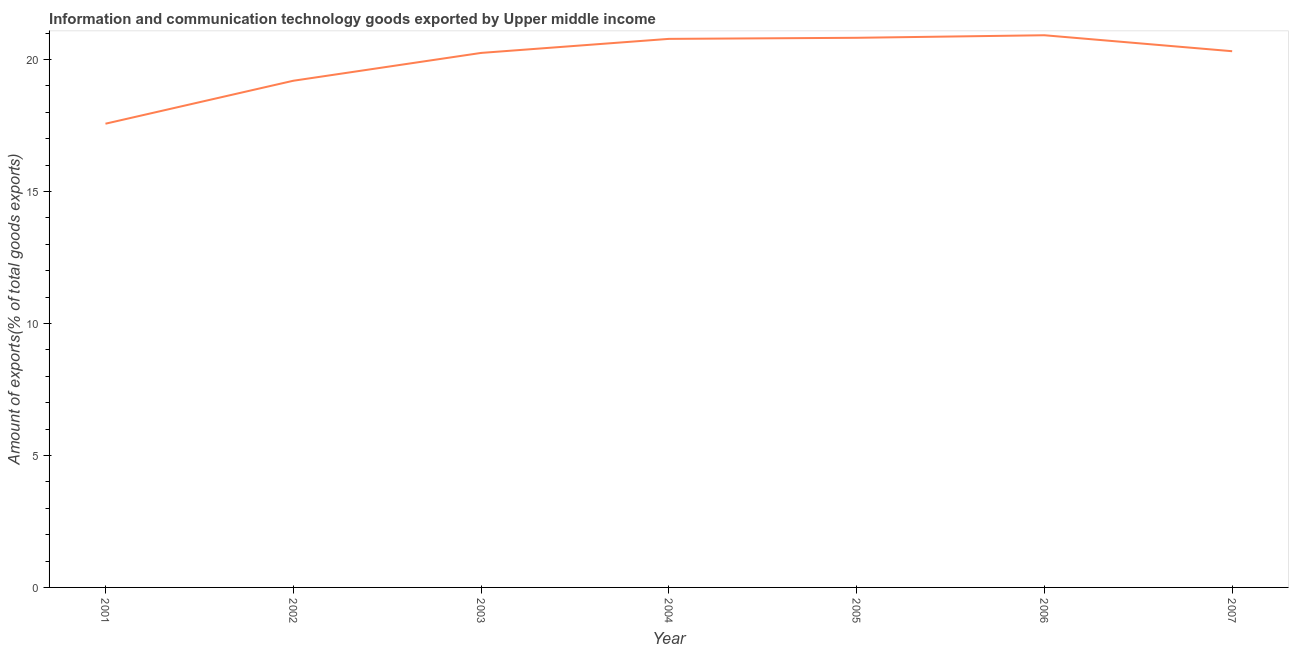What is the amount of ict goods exports in 2004?
Ensure brevity in your answer.  20.78. Across all years, what is the maximum amount of ict goods exports?
Offer a terse response. 20.92. Across all years, what is the minimum amount of ict goods exports?
Your answer should be very brief. 17.57. What is the sum of the amount of ict goods exports?
Provide a succinct answer. 139.87. What is the difference between the amount of ict goods exports in 2005 and 2007?
Make the answer very short. 0.51. What is the average amount of ict goods exports per year?
Provide a succinct answer. 19.98. What is the median amount of ict goods exports?
Ensure brevity in your answer.  20.32. In how many years, is the amount of ict goods exports greater than 12 %?
Provide a succinct answer. 7. Do a majority of the years between 2003 and 2002 (inclusive) have amount of ict goods exports greater than 15 %?
Your answer should be very brief. No. What is the ratio of the amount of ict goods exports in 2001 to that in 2002?
Ensure brevity in your answer.  0.92. Is the amount of ict goods exports in 2001 less than that in 2004?
Provide a short and direct response. Yes. Is the difference between the amount of ict goods exports in 2002 and 2006 greater than the difference between any two years?
Ensure brevity in your answer.  No. What is the difference between the highest and the second highest amount of ict goods exports?
Your answer should be compact. 0.1. What is the difference between the highest and the lowest amount of ict goods exports?
Offer a terse response. 3.35. In how many years, is the amount of ict goods exports greater than the average amount of ict goods exports taken over all years?
Make the answer very short. 5. How many lines are there?
Your answer should be compact. 1. What is the difference between two consecutive major ticks on the Y-axis?
Your response must be concise. 5. Are the values on the major ticks of Y-axis written in scientific E-notation?
Make the answer very short. No. Does the graph contain any zero values?
Keep it short and to the point. No. Does the graph contain grids?
Make the answer very short. No. What is the title of the graph?
Your answer should be very brief. Information and communication technology goods exported by Upper middle income. What is the label or title of the Y-axis?
Provide a succinct answer. Amount of exports(% of total goods exports). What is the Amount of exports(% of total goods exports) of 2001?
Keep it short and to the point. 17.57. What is the Amount of exports(% of total goods exports) in 2002?
Give a very brief answer. 19.2. What is the Amount of exports(% of total goods exports) in 2003?
Provide a short and direct response. 20.25. What is the Amount of exports(% of total goods exports) in 2004?
Provide a succinct answer. 20.78. What is the Amount of exports(% of total goods exports) in 2005?
Offer a terse response. 20.83. What is the Amount of exports(% of total goods exports) of 2006?
Your answer should be compact. 20.92. What is the Amount of exports(% of total goods exports) in 2007?
Your response must be concise. 20.32. What is the difference between the Amount of exports(% of total goods exports) in 2001 and 2002?
Ensure brevity in your answer.  -1.63. What is the difference between the Amount of exports(% of total goods exports) in 2001 and 2003?
Give a very brief answer. -2.68. What is the difference between the Amount of exports(% of total goods exports) in 2001 and 2004?
Ensure brevity in your answer.  -3.21. What is the difference between the Amount of exports(% of total goods exports) in 2001 and 2005?
Offer a very short reply. -3.26. What is the difference between the Amount of exports(% of total goods exports) in 2001 and 2006?
Give a very brief answer. -3.35. What is the difference between the Amount of exports(% of total goods exports) in 2001 and 2007?
Provide a succinct answer. -2.75. What is the difference between the Amount of exports(% of total goods exports) in 2002 and 2003?
Provide a succinct answer. -1.05. What is the difference between the Amount of exports(% of total goods exports) in 2002 and 2004?
Offer a terse response. -1.59. What is the difference between the Amount of exports(% of total goods exports) in 2002 and 2005?
Provide a succinct answer. -1.63. What is the difference between the Amount of exports(% of total goods exports) in 2002 and 2006?
Provide a short and direct response. -1.72. What is the difference between the Amount of exports(% of total goods exports) in 2002 and 2007?
Provide a short and direct response. -1.12. What is the difference between the Amount of exports(% of total goods exports) in 2003 and 2004?
Your answer should be very brief. -0.53. What is the difference between the Amount of exports(% of total goods exports) in 2003 and 2005?
Your answer should be very brief. -0.57. What is the difference between the Amount of exports(% of total goods exports) in 2003 and 2006?
Make the answer very short. -0.67. What is the difference between the Amount of exports(% of total goods exports) in 2003 and 2007?
Provide a short and direct response. -0.06. What is the difference between the Amount of exports(% of total goods exports) in 2004 and 2005?
Offer a terse response. -0.04. What is the difference between the Amount of exports(% of total goods exports) in 2004 and 2006?
Make the answer very short. -0.14. What is the difference between the Amount of exports(% of total goods exports) in 2004 and 2007?
Offer a very short reply. 0.47. What is the difference between the Amount of exports(% of total goods exports) in 2005 and 2006?
Your response must be concise. -0.1. What is the difference between the Amount of exports(% of total goods exports) in 2005 and 2007?
Make the answer very short. 0.51. What is the difference between the Amount of exports(% of total goods exports) in 2006 and 2007?
Ensure brevity in your answer.  0.6. What is the ratio of the Amount of exports(% of total goods exports) in 2001 to that in 2002?
Ensure brevity in your answer.  0.92. What is the ratio of the Amount of exports(% of total goods exports) in 2001 to that in 2003?
Your response must be concise. 0.87. What is the ratio of the Amount of exports(% of total goods exports) in 2001 to that in 2004?
Provide a short and direct response. 0.84. What is the ratio of the Amount of exports(% of total goods exports) in 2001 to that in 2005?
Your response must be concise. 0.84. What is the ratio of the Amount of exports(% of total goods exports) in 2001 to that in 2006?
Offer a terse response. 0.84. What is the ratio of the Amount of exports(% of total goods exports) in 2001 to that in 2007?
Make the answer very short. 0.86. What is the ratio of the Amount of exports(% of total goods exports) in 2002 to that in 2003?
Provide a short and direct response. 0.95. What is the ratio of the Amount of exports(% of total goods exports) in 2002 to that in 2004?
Provide a short and direct response. 0.92. What is the ratio of the Amount of exports(% of total goods exports) in 2002 to that in 2005?
Your response must be concise. 0.92. What is the ratio of the Amount of exports(% of total goods exports) in 2002 to that in 2006?
Offer a very short reply. 0.92. What is the ratio of the Amount of exports(% of total goods exports) in 2002 to that in 2007?
Offer a terse response. 0.94. What is the ratio of the Amount of exports(% of total goods exports) in 2003 to that in 2007?
Offer a terse response. 1. What is the ratio of the Amount of exports(% of total goods exports) in 2005 to that in 2007?
Make the answer very short. 1.02. 